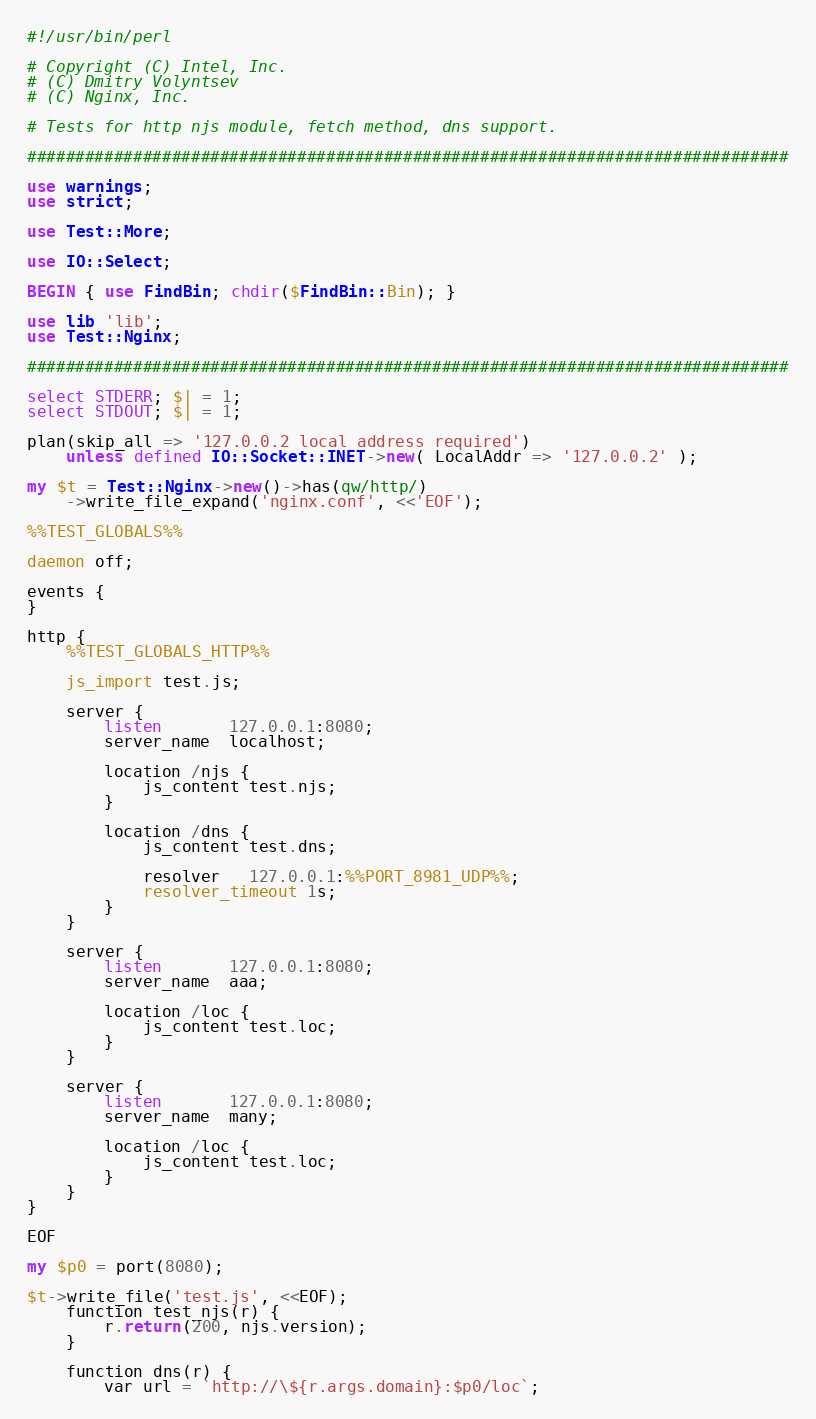Convert code to text. <code><loc_0><loc_0><loc_500><loc_500><_Perl_>#!/usr/bin/perl

# Copyright (C) Intel, Inc.
# (C) Dmitry Volyntsev
# (C) Nginx, Inc.

# Tests for http njs module, fetch method, dns support.

###############################################################################

use warnings;
use strict;

use Test::More;

use IO::Select;

BEGIN { use FindBin; chdir($FindBin::Bin); }

use lib 'lib';
use Test::Nginx;

###############################################################################

select STDERR; $| = 1;
select STDOUT; $| = 1;

plan(skip_all => '127.0.0.2 local address required')
    unless defined IO::Socket::INET->new( LocalAddr => '127.0.0.2' );

my $t = Test::Nginx->new()->has(qw/http/)
    ->write_file_expand('nginx.conf', <<'EOF');

%%TEST_GLOBALS%%

daemon off;

events {
}

http {
    %%TEST_GLOBALS_HTTP%%

    js_import test.js;

    server {
        listen       127.0.0.1:8080;
        server_name  localhost;

        location /njs {
            js_content test.njs;
        }

        location /dns {
            js_content test.dns;

            resolver   127.0.0.1:%%PORT_8981_UDP%%;
            resolver_timeout 1s;
        }
    }

    server {
        listen       127.0.0.1:8080;
        server_name  aaa;

        location /loc {
            js_content test.loc;
        }
    }

    server {
        listen       127.0.0.1:8080;
        server_name  many;

        location /loc {
            js_content test.loc;
        }
    }
}

EOF

my $p0 = port(8080);

$t->write_file('test.js', <<EOF);
    function test_njs(r) {
        r.return(200, njs.version);
    }

    function dns(r) {
        var url = `http://\${r.args.domain}:$p0/loc`;
</code> 